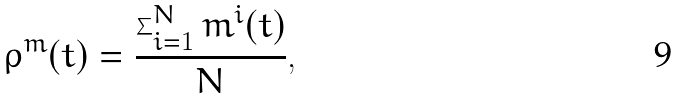Convert formula to latex. <formula><loc_0><loc_0><loc_500><loc_500>\rho ^ { m } ( t ) = \frac { \sum _ { i = 1 } ^ { N } m ^ { i } ( t ) } { N } ,</formula> 